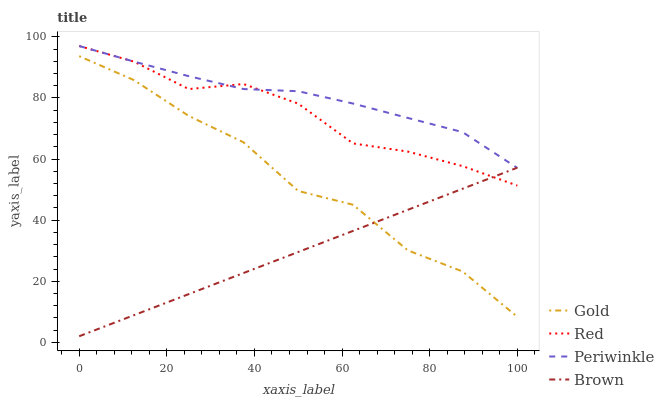Does Brown have the minimum area under the curve?
Answer yes or no. Yes. Does Periwinkle have the maximum area under the curve?
Answer yes or no. Yes. Does Red have the minimum area under the curve?
Answer yes or no. No. Does Red have the maximum area under the curve?
Answer yes or no. No. Is Brown the smoothest?
Answer yes or no. Yes. Is Gold the roughest?
Answer yes or no. Yes. Is Periwinkle the smoothest?
Answer yes or no. No. Is Periwinkle the roughest?
Answer yes or no. No. Does Brown have the lowest value?
Answer yes or no. Yes. Does Red have the lowest value?
Answer yes or no. No. Does Red have the highest value?
Answer yes or no. Yes. Does Gold have the highest value?
Answer yes or no. No. Is Gold less than Periwinkle?
Answer yes or no. Yes. Is Periwinkle greater than Gold?
Answer yes or no. Yes. Does Periwinkle intersect Red?
Answer yes or no. Yes. Is Periwinkle less than Red?
Answer yes or no. No. Is Periwinkle greater than Red?
Answer yes or no. No. Does Gold intersect Periwinkle?
Answer yes or no. No. 